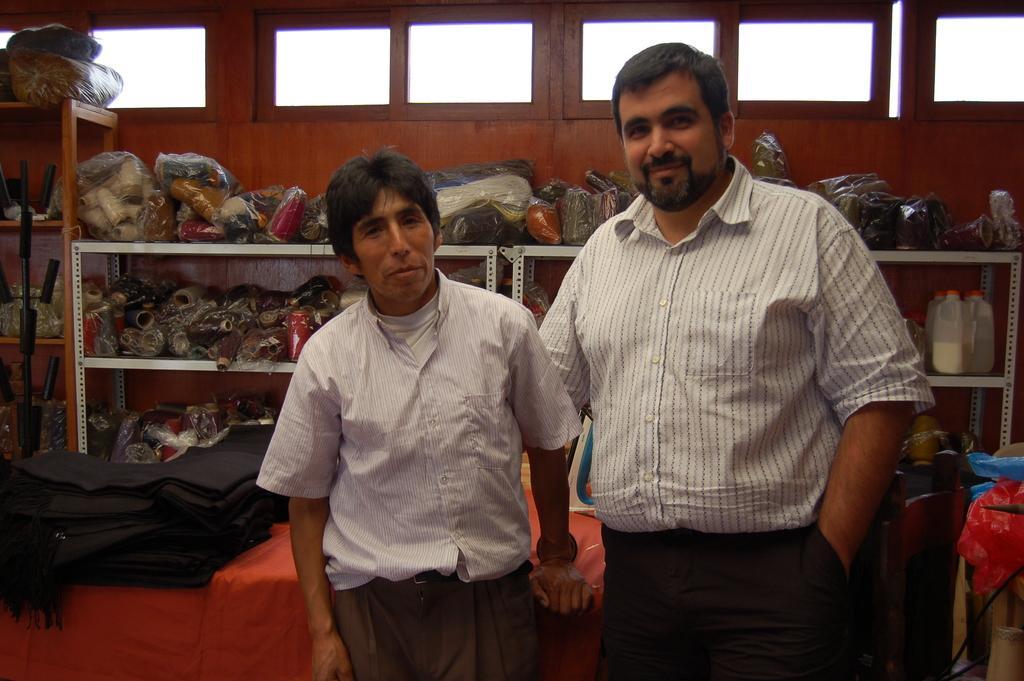Please provide a concise description of this image. This is an inside view. Here I can see two men standing, smiling and giving pose for the picture. At the back of these people there is a table which is covered with a cloth. On this table a bag and some other objects are placed. In the background there are few bottles, bags and some other objects are placed in the racks. At the top of the image there is a wall with glass windows. 